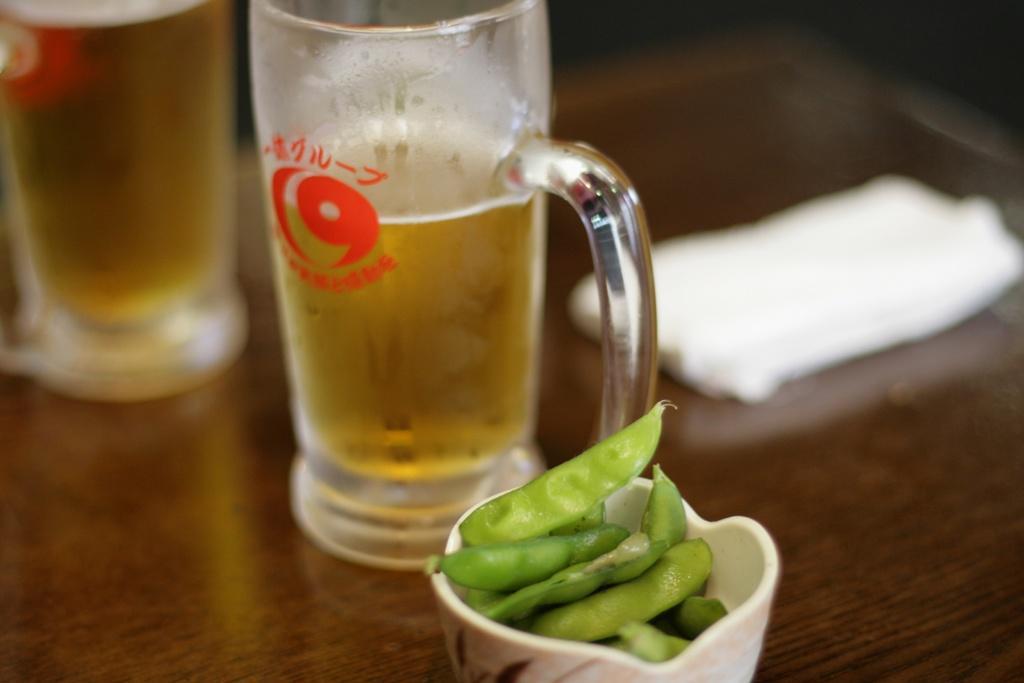Could you give a brief overview of what you see in this image? In this picture there are two glasses of beer, a cup, cloth, beans placed on a table. 